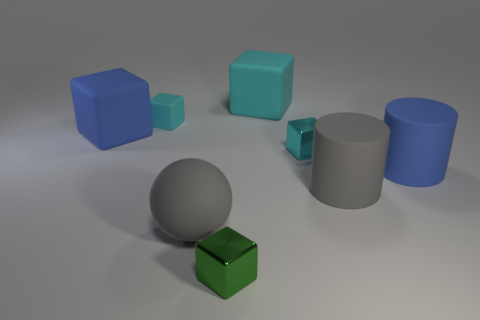Subtract all red cylinders. How many cyan blocks are left? 3 Subtract all green blocks. How many blocks are left? 4 Subtract all cyan metallic cubes. How many cubes are left? 4 Subtract all brown cubes. Subtract all yellow cylinders. How many cubes are left? 5 Add 2 big green cylinders. How many objects exist? 10 Subtract all cubes. How many objects are left? 3 Add 8 green blocks. How many green blocks are left? 9 Add 1 purple shiny cylinders. How many purple shiny cylinders exist? 1 Subtract 0 blue balls. How many objects are left? 8 Subtract all small cyan matte cylinders. Subtract all big rubber balls. How many objects are left? 7 